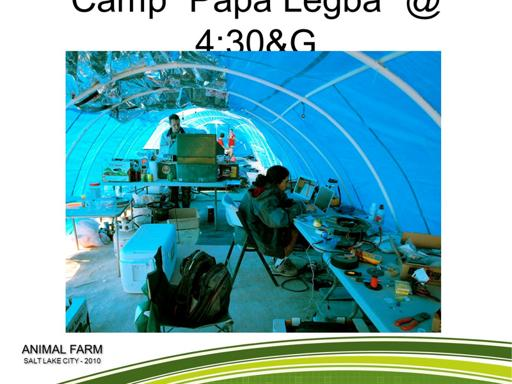What kind of equipment can be seen in this setup? The image shows various pieces of electronic equipment, including laptops, a generator or large power supply unit, and multiple cables and components spread across the tables. Such tools suggest that the event involves detailed technical work or digital projects. 